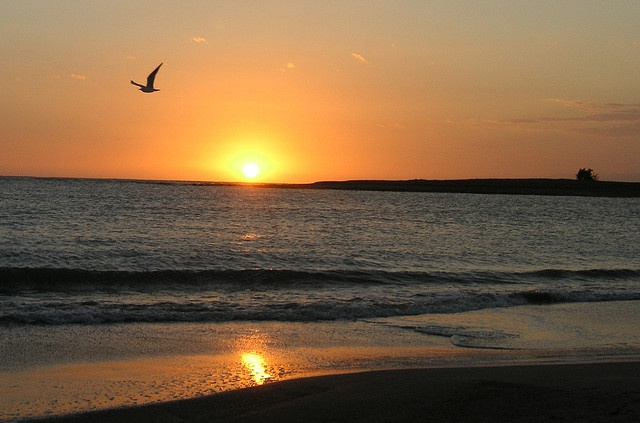Describe the objects in this image and their specific colors. I can see a bird in tan, black, maroon, and gray tones in this image. 